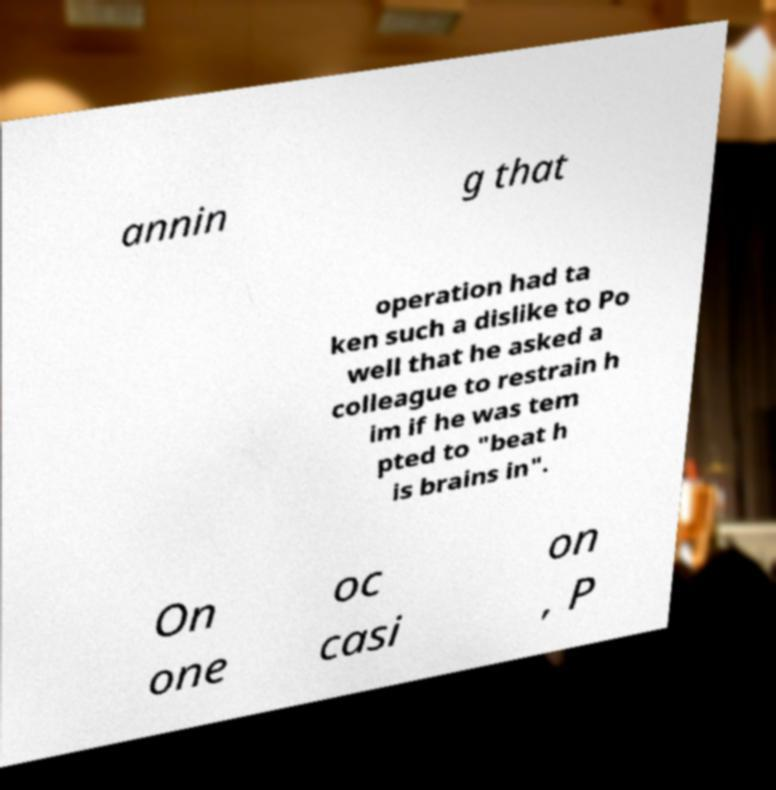Can you read and provide the text displayed in the image?This photo seems to have some interesting text. Can you extract and type it out for me? annin g that operation had ta ken such a dislike to Po well that he asked a colleague to restrain h im if he was tem pted to "beat h is brains in". On one oc casi on , P 